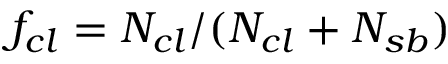<formula> <loc_0><loc_0><loc_500><loc_500>f _ { c l } = N _ { c l } / ( N _ { c l } + N _ { s b } )</formula> 